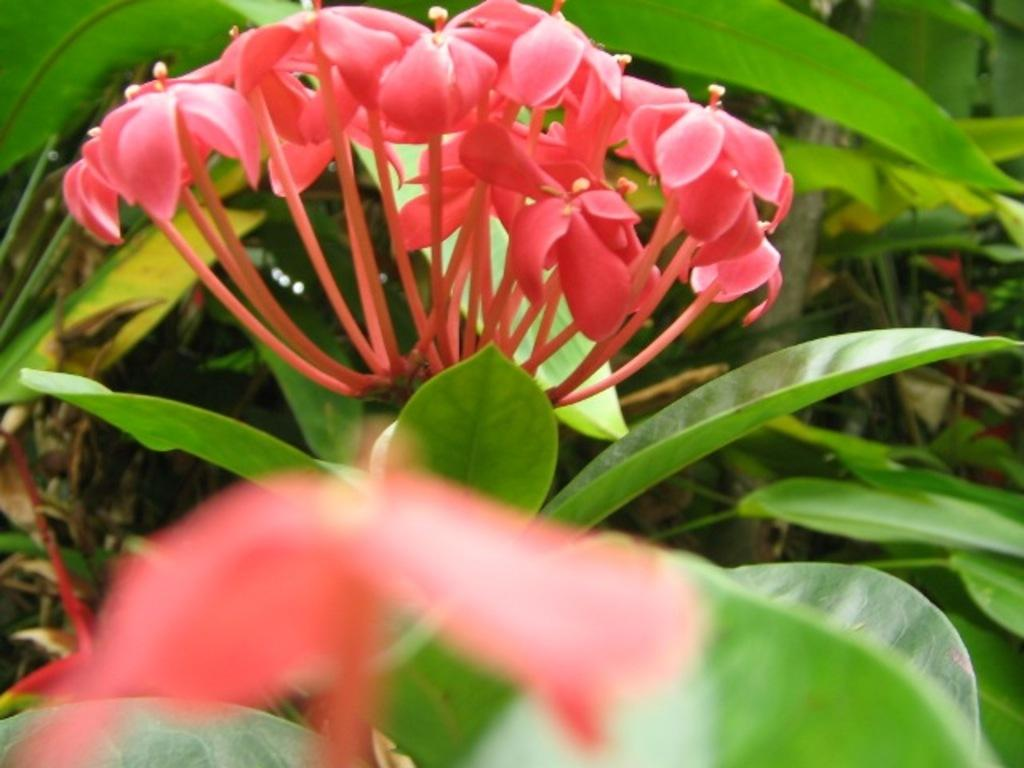What type of living organisms can be seen in the image? Flowers and plants are visible in the image. What color are the leaves in the image? The leaves in the image are green. Can you describe the plants in the image? There are plants in the image, which include flowers and green leaves. What other objects are present in the image besides plants? There are other objects present in the image, but their specific details are not mentioned in the provided facts. How many friends are sitting with the father in the image? There is no father or friends present in the image; it features plants and flowers. 